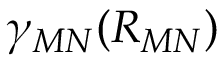Convert formula to latex. <formula><loc_0><loc_0><loc_500><loc_500>\gamma _ { M N } ( R _ { M N } )</formula> 